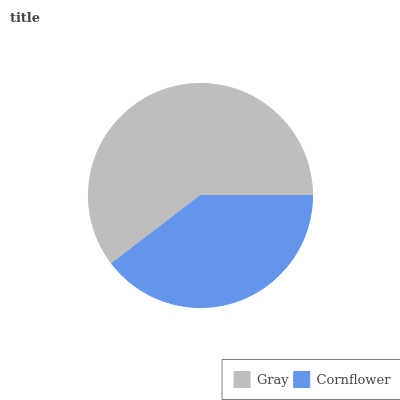Is Cornflower the minimum?
Answer yes or no. Yes. Is Gray the maximum?
Answer yes or no. Yes. Is Cornflower the maximum?
Answer yes or no. No. Is Gray greater than Cornflower?
Answer yes or no. Yes. Is Cornflower less than Gray?
Answer yes or no. Yes. Is Cornflower greater than Gray?
Answer yes or no. No. Is Gray less than Cornflower?
Answer yes or no. No. Is Gray the high median?
Answer yes or no. Yes. Is Cornflower the low median?
Answer yes or no. Yes. Is Cornflower the high median?
Answer yes or no. No. Is Gray the low median?
Answer yes or no. No. 